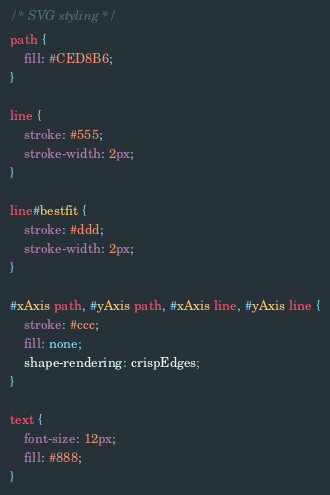Convert code to text. <code><loc_0><loc_0><loc_500><loc_500><_CSS_>/* SVG styling */
path {
	fill: #CED8B6;
}

line {
	stroke: #555;
	stroke-width: 2px;
}

line#bestfit {
	stroke: #ddd;
	stroke-width: 2px;
}

#xAxis path, #yAxis path, #xAxis line, #yAxis line {
	stroke: #ccc;
	fill: none;
	shape-rendering: crispEdges;
}

text {
	font-size: 12px;
	fill: #888;
}
</code> 